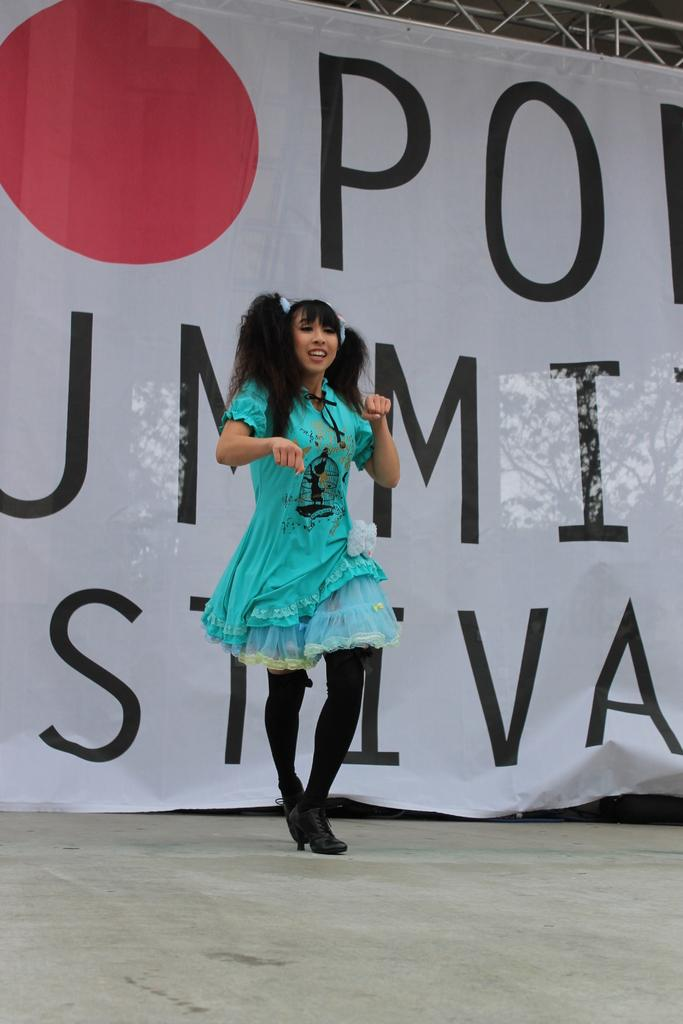What is the woman in the image doing? The woman is dancing in the image. What can be seen hanging above the woman? There is a lighting truss at the top of the image. What is written or displayed on the banner in the image? The banner has letters, but without more information, we cannot determine the specific message. What is the surface beneath the woman's feet? There is a floor visible in the image. Where is the sofa located in the image? There is no sofa present in the image. What type of stem is visible in the image? There is no stem present in the image. 